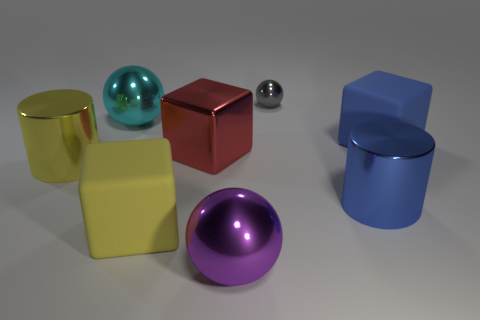Add 1 tiny things. How many objects exist? 9 Subtract all big matte blocks. How many blocks are left? 1 Subtract all gray balls. How many balls are left? 2 Subtract all cylinders. How many objects are left? 6 Subtract 1 blocks. How many blocks are left? 2 Subtract 0 purple cylinders. How many objects are left? 8 Subtract all gray cylinders. Subtract all red balls. How many cylinders are left? 2 Subtract all big yellow rubber cubes. Subtract all cyan metal objects. How many objects are left? 6 Add 5 large yellow metal cylinders. How many large yellow metal cylinders are left? 6 Add 3 big purple objects. How many big purple objects exist? 4 